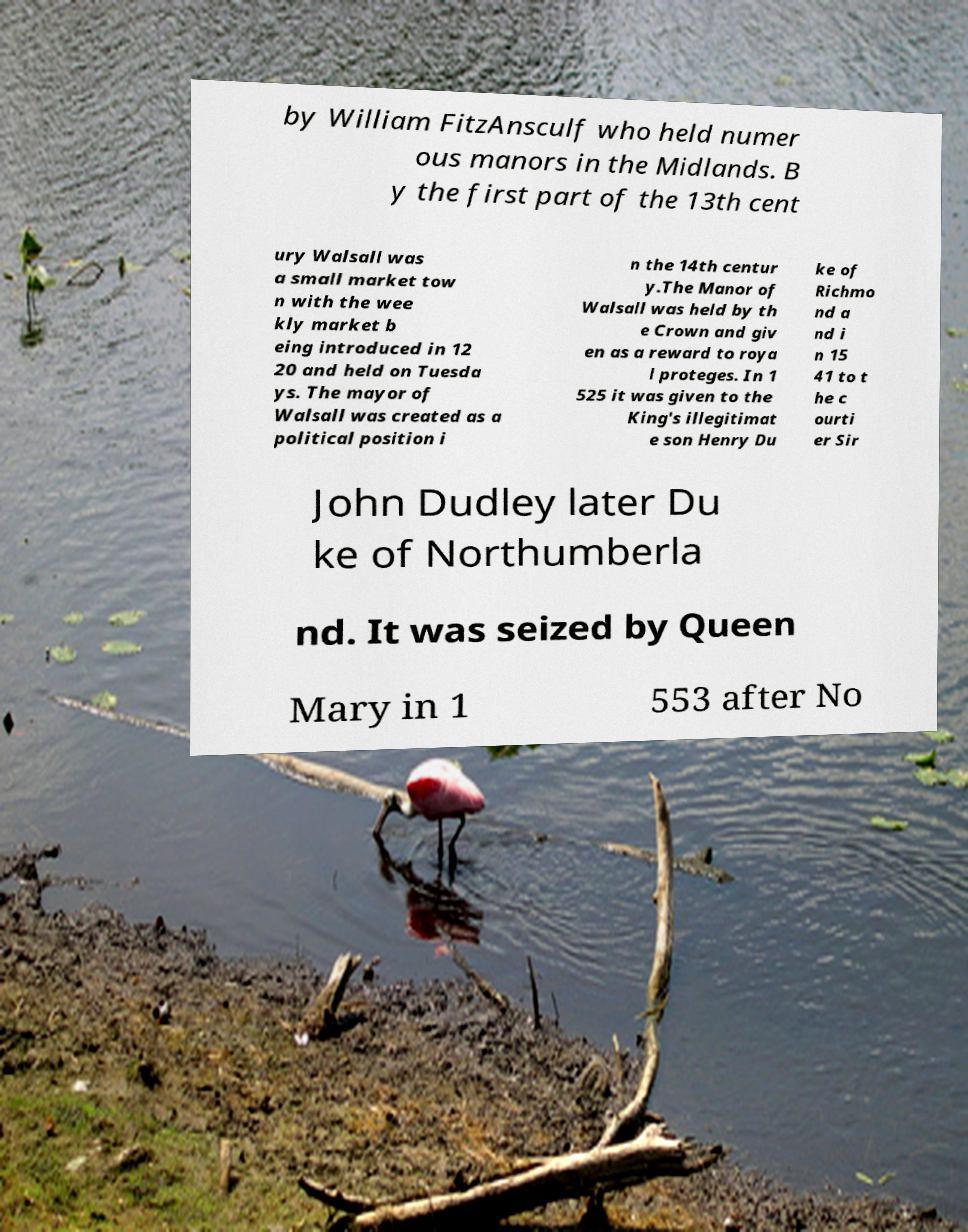There's text embedded in this image that I need extracted. Can you transcribe it verbatim? by William FitzAnsculf who held numer ous manors in the Midlands. B y the first part of the 13th cent ury Walsall was a small market tow n with the wee kly market b eing introduced in 12 20 and held on Tuesda ys. The mayor of Walsall was created as a political position i n the 14th centur y.The Manor of Walsall was held by th e Crown and giv en as a reward to roya l proteges. In 1 525 it was given to the King's illegitimat e son Henry Du ke of Richmo nd a nd i n 15 41 to t he c ourti er Sir John Dudley later Du ke of Northumberla nd. It was seized by Queen Mary in 1 553 after No 